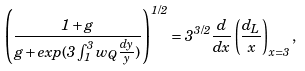<formula> <loc_0><loc_0><loc_500><loc_500>\left ( \frac { 1 + g } { g + e x p ( 3 \int _ { 1 } ^ { 3 } w _ { Q } \frac { d y } { y } ) } \right ) ^ { 1 / 2 } = 3 ^ { 3 / 2 } \frac { d } { d x } \left ( \frac { d _ { L } } { x } \right ) _ { x = 3 } ,</formula> 